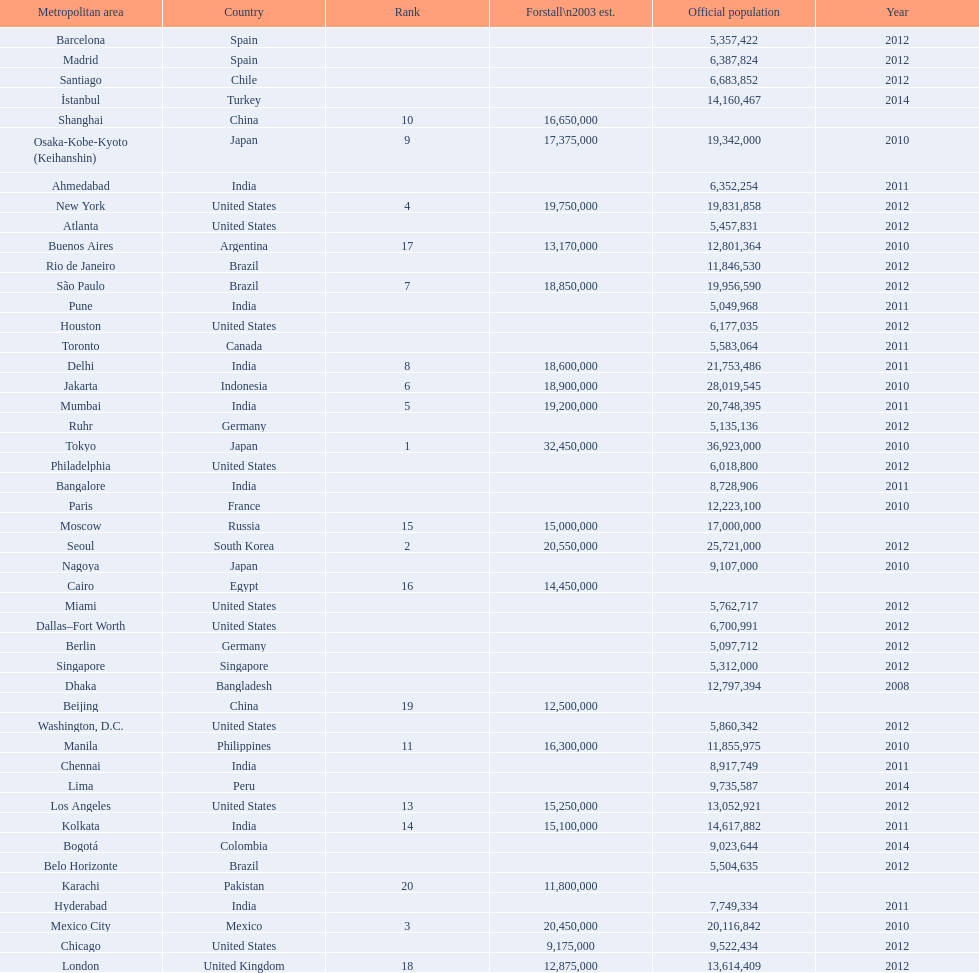Which population is mentioned before 5,357,422? 8,728,906. 